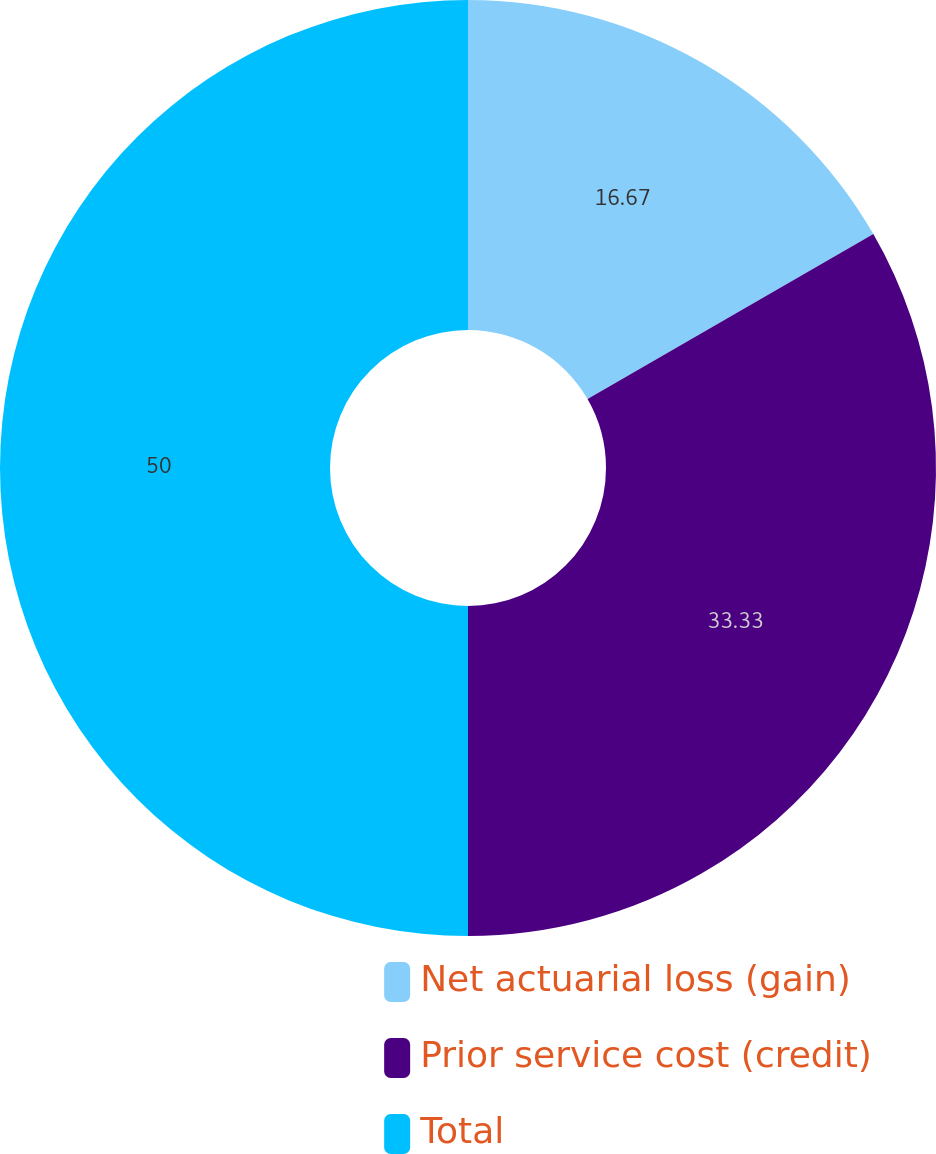<chart> <loc_0><loc_0><loc_500><loc_500><pie_chart><fcel>Net actuarial loss (gain)<fcel>Prior service cost (credit)<fcel>Total<nl><fcel>16.67%<fcel>33.33%<fcel>50.0%<nl></chart> 